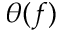Convert formula to latex. <formula><loc_0><loc_0><loc_500><loc_500>\theta ( f )</formula> 